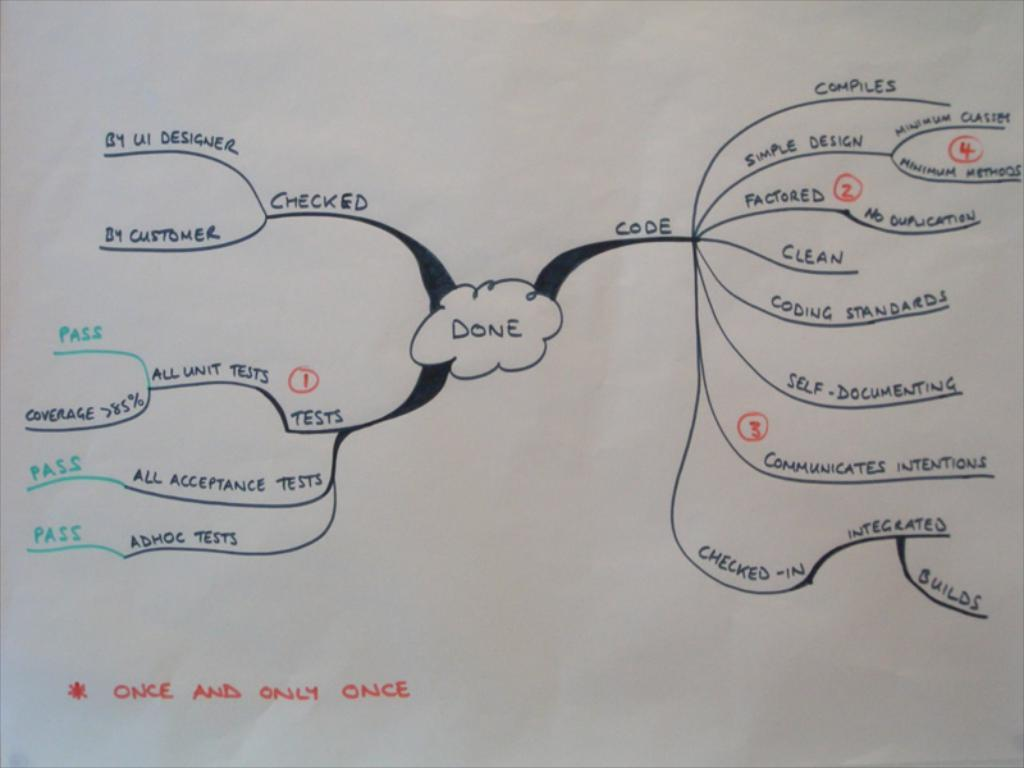<image>
Summarize the visual content of the image. A paper with a drawn chart is asterisked with once and only once. 